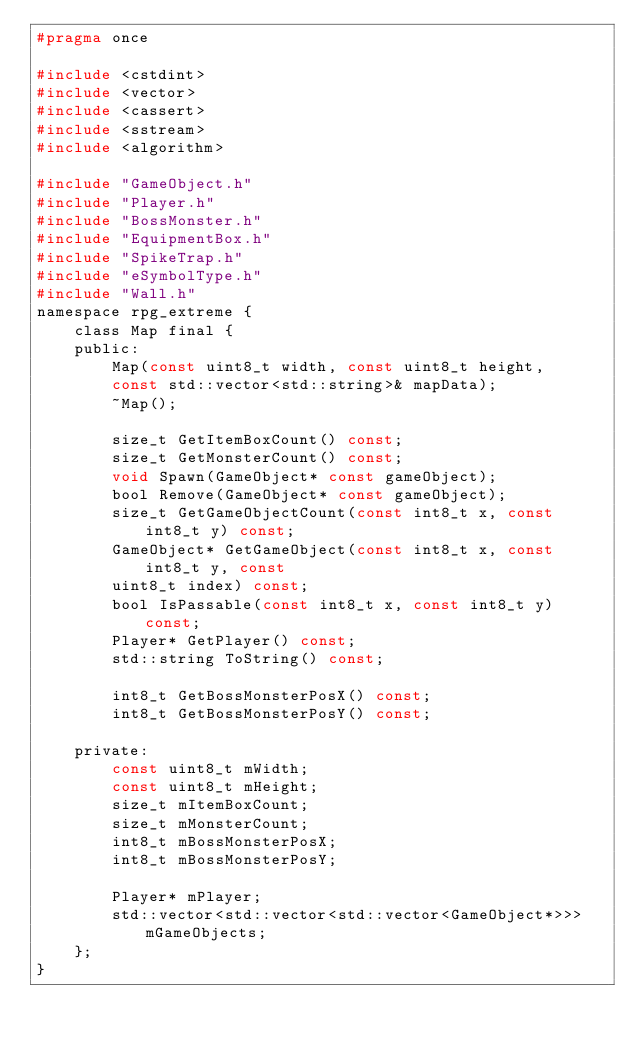Convert code to text. <code><loc_0><loc_0><loc_500><loc_500><_C_>#pragma once

#include <cstdint>
#include <vector>
#include <cassert>
#include <sstream>
#include <algorithm>

#include "GameObject.h"
#include "Player.h"
#include "BossMonster.h"
#include "EquipmentBox.h"
#include "SpikeTrap.h"
#include "eSymbolType.h"
#include "Wall.h"
namespace rpg_extreme {
    class Map final {
    public:
        Map(const uint8_t width, const uint8_t height,
        const std::vector<std::string>& mapData);
        ~Map();

        size_t GetItemBoxCount() const;
        size_t GetMonsterCount() const;
        void Spawn(GameObject* const gameObject);
        bool Remove(GameObject* const gameObject);
        size_t GetGameObjectCount(const int8_t x, const int8_t y) const;
        GameObject* GetGameObject(const int8_t x, const int8_t y, const
        uint8_t index) const;
        bool IsPassable(const int8_t x, const int8_t y) const;
        Player* GetPlayer() const;
        std::string ToString() const;

        int8_t GetBossMonsterPosX() const;
        int8_t GetBossMonsterPosY() const;

    private:
        const uint8_t mWidth;
        const uint8_t mHeight;
        size_t mItemBoxCount;
        size_t mMonsterCount;
        int8_t mBossMonsterPosX;
        int8_t mBossMonsterPosY;

        Player* mPlayer;
        std::vector<std::vector<std::vector<GameObject*>>> mGameObjects;
    };
}</code> 